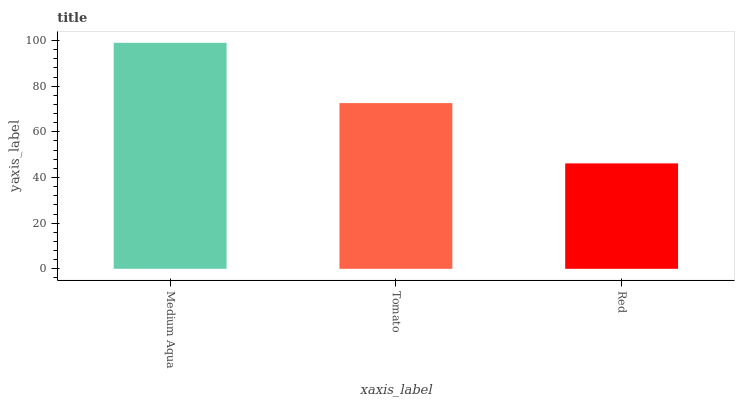Is Red the minimum?
Answer yes or no. Yes. Is Medium Aqua the maximum?
Answer yes or no. Yes. Is Tomato the minimum?
Answer yes or no. No. Is Tomato the maximum?
Answer yes or no. No. Is Medium Aqua greater than Tomato?
Answer yes or no. Yes. Is Tomato less than Medium Aqua?
Answer yes or no. Yes. Is Tomato greater than Medium Aqua?
Answer yes or no. No. Is Medium Aqua less than Tomato?
Answer yes or no. No. Is Tomato the high median?
Answer yes or no. Yes. Is Tomato the low median?
Answer yes or no. Yes. Is Red the high median?
Answer yes or no. No. Is Red the low median?
Answer yes or no. No. 